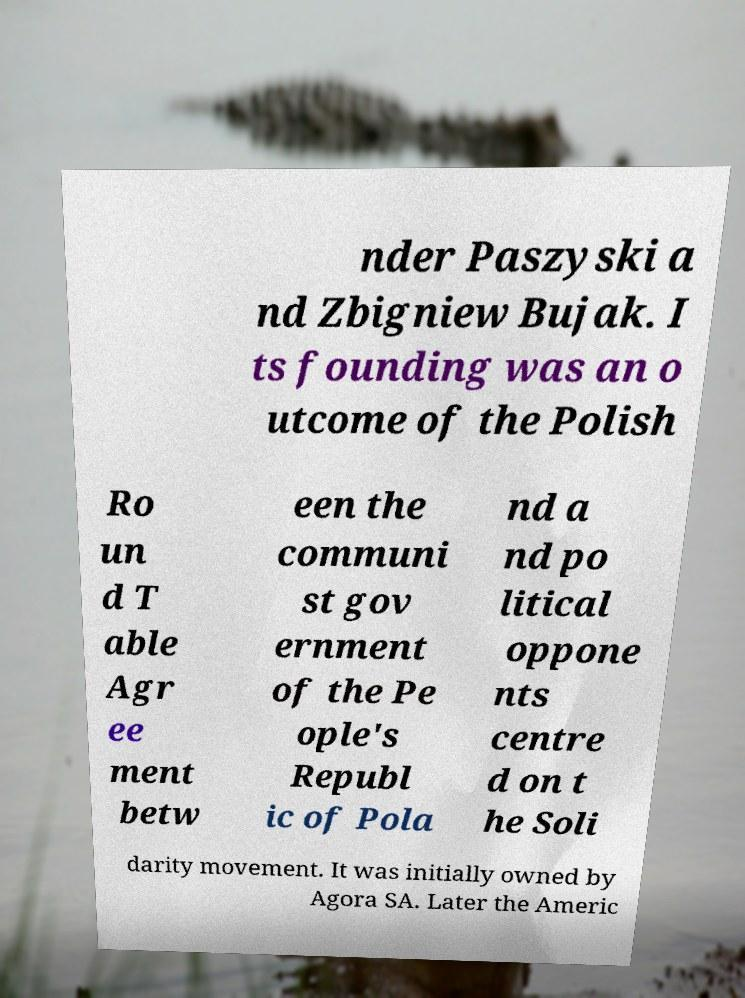Can you read and provide the text displayed in the image?This photo seems to have some interesting text. Can you extract and type it out for me? nder Paszyski a nd Zbigniew Bujak. I ts founding was an o utcome of the Polish Ro un d T able Agr ee ment betw een the communi st gov ernment of the Pe ople's Republ ic of Pola nd a nd po litical oppone nts centre d on t he Soli darity movement. It was initially owned by Agora SA. Later the Americ 